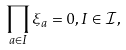Convert formula to latex. <formula><loc_0><loc_0><loc_500><loc_500>\prod _ { a \in I } \xi _ { a } = 0 , I \in \mathcal { I } ,</formula> 